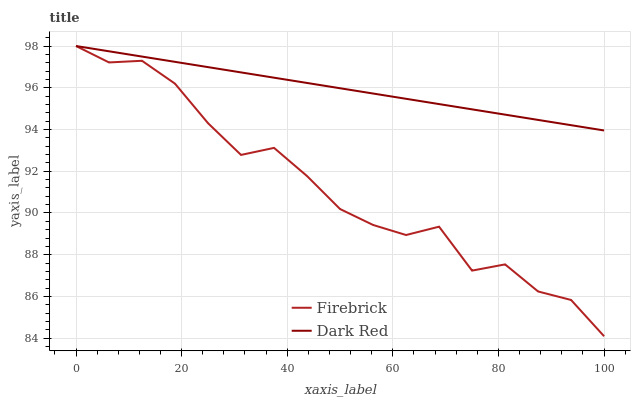Does Firebrick have the minimum area under the curve?
Answer yes or no. Yes. Does Dark Red have the maximum area under the curve?
Answer yes or no. Yes. Does Firebrick have the maximum area under the curve?
Answer yes or no. No. Is Dark Red the smoothest?
Answer yes or no. Yes. Is Firebrick the roughest?
Answer yes or no. Yes. Is Firebrick the smoothest?
Answer yes or no. No. Does Firebrick have the highest value?
Answer yes or no. Yes. Does Dark Red intersect Firebrick?
Answer yes or no. Yes. Is Dark Red less than Firebrick?
Answer yes or no. No. Is Dark Red greater than Firebrick?
Answer yes or no. No. 